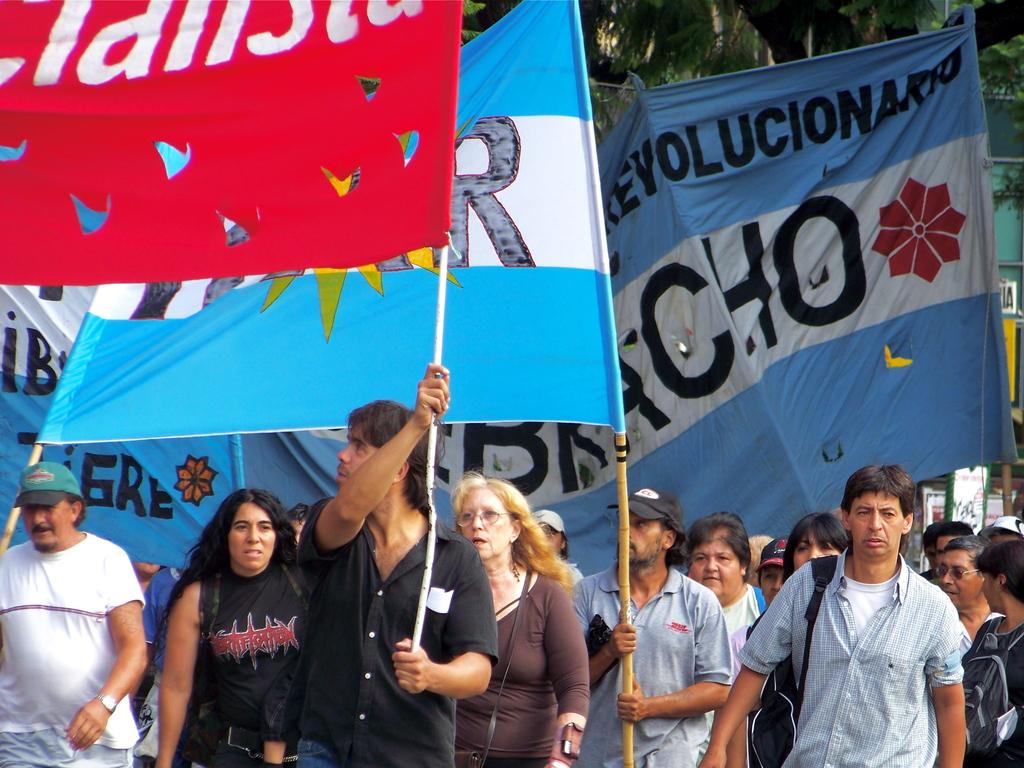What color is the bracho flag?
Make the answer very short. Answering does not require reading text in the image. What is the blue banner calling for?
Keep it short and to the point. Revolution. 